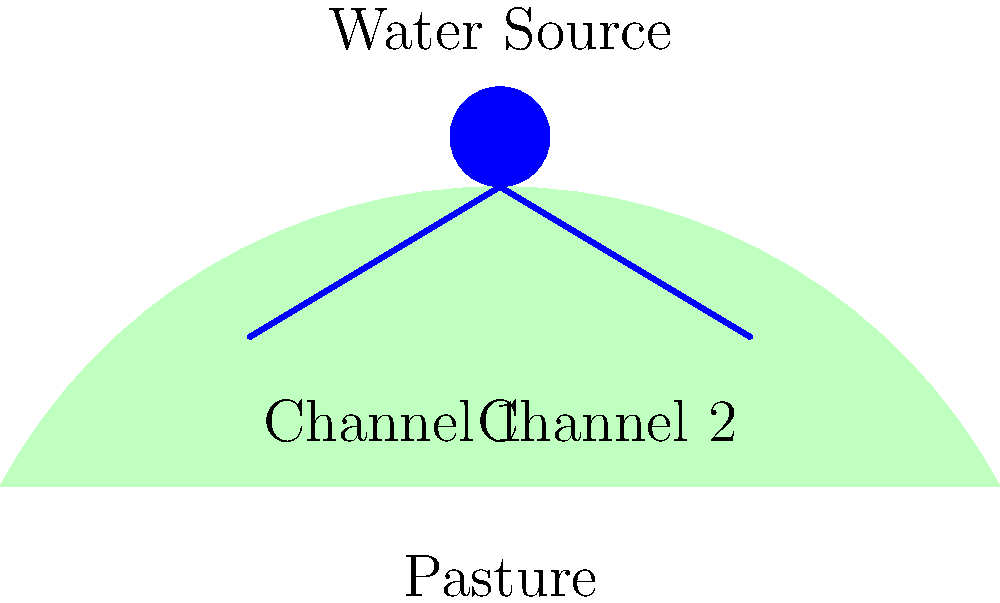You need to design a simple irrigation system for your pasture using gravity flow from a natural spring on a nearby hill. The spring is about 10 meters higher than your pasture. What's the most important factor to consider when laying out the irrigation channels to ensure efficient water distribution? To design an efficient gravity-flow irrigation system for a pasture, we need to consider several factors. However, the most important one is the slope of the irrigation channels. Here's why:

1. Gravity is the driving force: The water flows downhill naturally, without the need for pumps.

2. Slope affects flow rate: The steeper the slope, the faster the water will flow.

3. Even distribution: We want to ensure water reaches all parts of the pasture.

4. Erosion prevention: Too steep a slope can cause erosion and damage to the channels.

5. Optimal slope: A gentle, consistent slope (typically between 1-3%) allows for efficient water flow without causing erosion.

6. Layout planning: The channels should follow the natural contours of the land to maintain a consistent slope.

7. Multiple channels: Using more than one channel helps distribute water evenly across the pasture.

By focusing on the slope of the irrigation channels, you can create a system that efficiently uses gravity to distribute water throughout your pasture without the need for complex technology or powered pumps.
Answer: The slope of the irrigation channels 